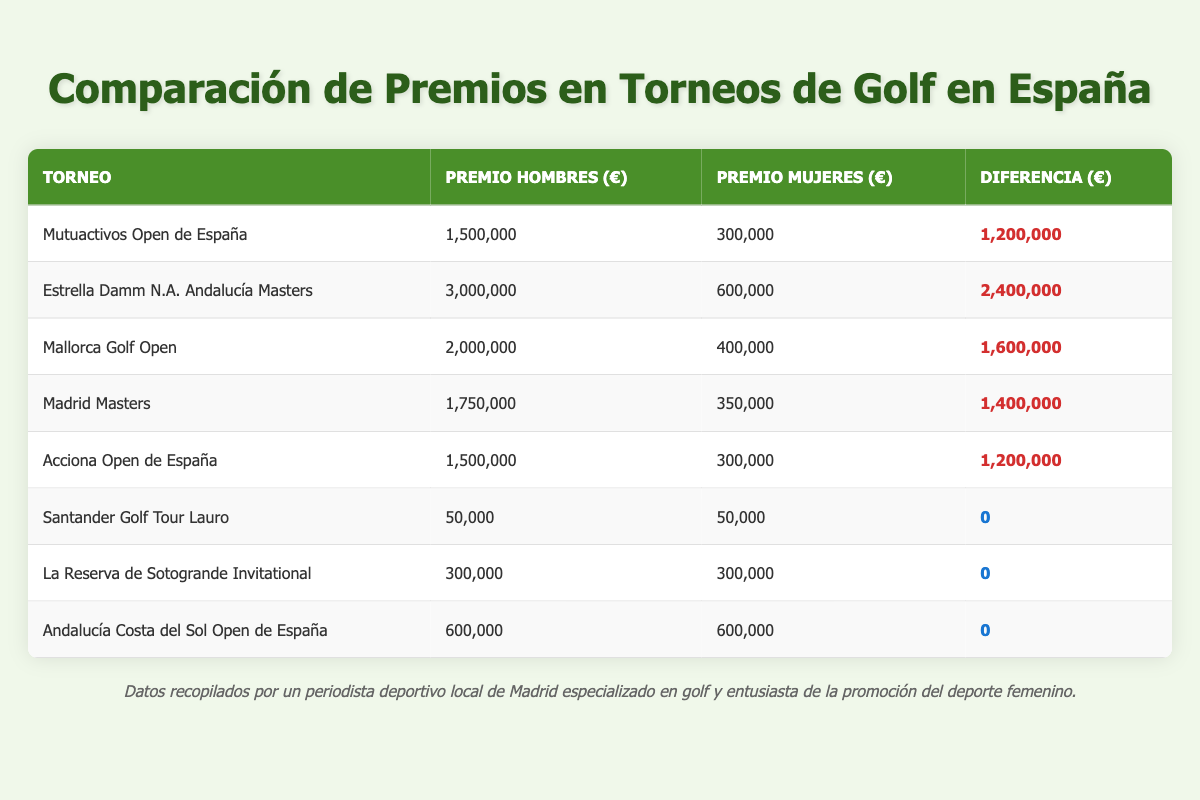What is the total prize money for the Estrella Damm N.A. Andalucía Masters? The table shows that the prize money for the Estrella Damm N.A. Andalucía Masters is 3,000,000 € for men and 600,000 € for women. Adding these together gives 3,000,000 + 600,000 = 3,600,000 €.
Answer: 3,600,000 € Which tournament has the largest difference in prize money between men and women? The largest difference can be found by looking at the "Difference (€)" column. The Mutuactivos Open de España has a difference of 1,200,000 €, the Estrella Damm N.A. Andalucía Masters has 2,400,000 €, and others can be checked. The highest is indeed 2,400,000 € for the Estrella Damm N.A. Andalucía Masters.
Answer: Estrella Damm N.A. Andalucía Masters How much more prize money do men receive than women in the Mallorca Golf Open? The table states that in the Mallorca Golf Open, men's prize money is 2,000,000 € and women's prize money is 400,000 €. The difference can be calculated by subtracting women's from men's: 2,000,000 - 400,000 = 1,600,000 €.
Answer: 1,600,000 € Is the prize money equal for both genders in the Santander Golf Tour Lauro? The table clearly shows that both men's and women's prize money is 50,000 €. Since these values are equal, the answer is yes.
Answer: Yes What is the average prize money for women's golf in the listed tournaments? To find the average, first sum the women's prize money from all tournaments: 300,000 + 600,000 + 400,000 + 350,000 + 300,000 + 50,000 + 300,000 + 600,000 = 2,850,000 €. There are 8 tournaments, so the average is 2,850,000 / 8 = 356,250 €.
Answer: 356,250 € How much total prize money was awarded in men's tournaments compared to women's tournaments? To find the total prize money for both genders, we sum separately: For men's tournaments: 1,500,000 + 3,000,000 + 2,000,000 + 1,750,000 + 1,500,000 + 50,000 + 300,000 + 600,000 = 11,700,000 €. For women's tournaments: 300,000 + 600,000 + 400,000 + 350,000 + 300,000 + 50,000 + 300,000 + 600,000 = 2,850,000 €. Therefore, men's tournaments awarded 11,700,000 € and women's 2,850,000 €.
Answer: Men's 11,700,000 €, Women's 2,850,000 € Do both La Reserva de Sotogrande Invitational and Andalucía Costa del Sol Open de España have the same prize money for women? The table indicates that both tournaments have 300,000 € prize for women, confirming they are equal.
Answer: Yes What is the total difference in prize money between men and women across all tournaments? To calculate the total difference, sum the differences from the "Difference (€)" column: 1,200,000 + 2,400,000 + 1,600,000 + 1,400,000 + 1,200,000 + 0 + 0 + 0 = 7,800,000 €. This gives the total difference for all tournaments.
Answer: 7,800,000 € 